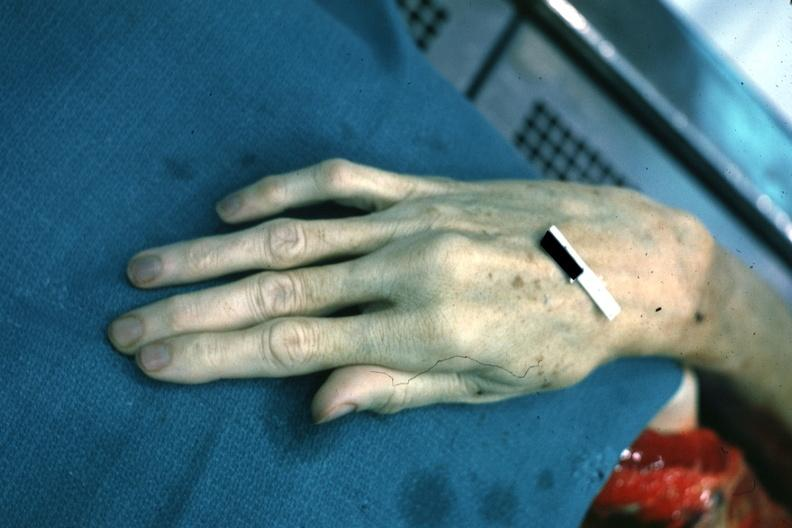s marfans syndrome present?
Answer the question using a single word or phrase. Yes 